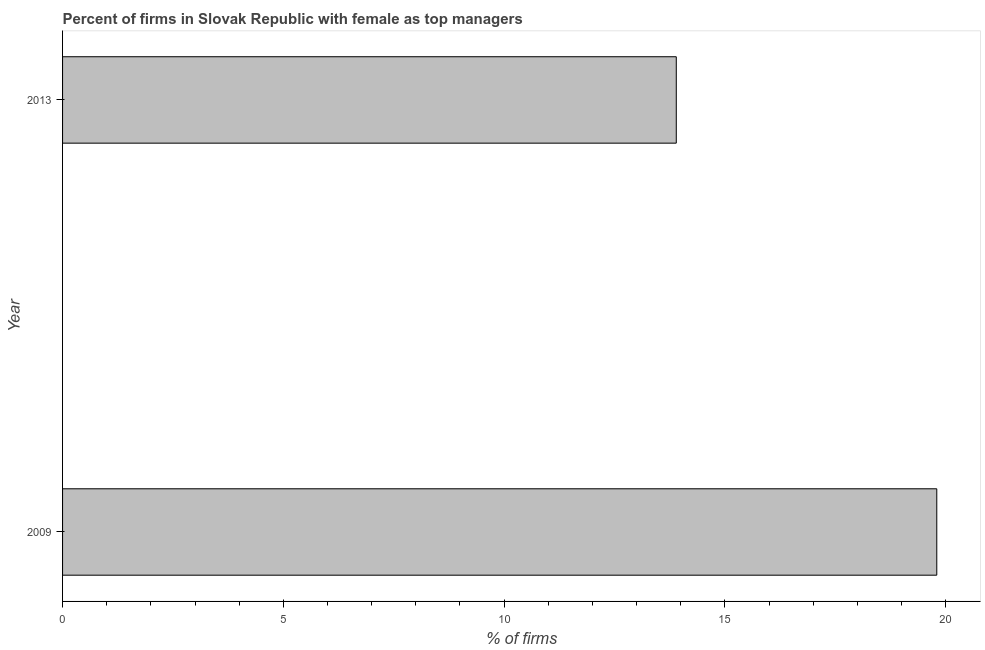Does the graph contain any zero values?
Offer a terse response. No. Does the graph contain grids?
Provide a succinct answer. No. What is the title of the graph?
Offer a terse response. Percent of firms in Slovak Republic with female as top managers. What is the label or title of the X-axis?
Make the answer very short. % of firms. What is the label or title of the Y-axis?
Your answer should be compact. Year. Across all years, what is the maximum percentage of firms with female as top manager?
Give a very brief answer. 19.8. Across all years, what is the minimum percentage of firms with female as top manager?
Keep it short and to the point. 13.9. In which year was the percentage of firms with female as top manager minimum?
Give a very brief answer. 2013. What is the sum of the percentage of firms with female as top manager?
Your response must be concise. 33.7. What is the difference between the percentage of firms with female as top manager in 2009 and 2013?
Make the answer very short. 5.9. What is the average percentage of firms with female as top manager per year?
Provide a short and direct response. 16.85. What is the median percentage of firms with female as top manager?
Your answer should be compact. 16.85. In how many years, is the percentage of firms with female as top manager greater than 3 %?
Ensure brevity in your answer.  2. What is the ratio of the percentage of firms with female as top manager in 2009 to that in 2013?
Provide a short and direct response. 1.42. Is the percentage of firms with female as top manager in 2009 less than that in 2013?
Offer a terse response. No. Are all the bars in the graph horizontal?
Offer a very short reply. Yes. Are the values on the major ticks of X-axis written in scientific E-notation?
Provide a short and direct response. No. What is the % of firms of 2009?
Ensure brevity in your answer.  19.8. What is the ratio of the % of firms in 2009 to that in 2013?
Offer a very short reply. 1.42. 